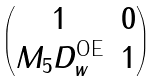<formula> <loc_0><loc_0><loc_500><loc_500>\begin{pmatrix} 1 & 0 \\ M _ { 5 } D _ { w } ^ { \text {OE} } & 1 \end{pmatrix}</formula> 